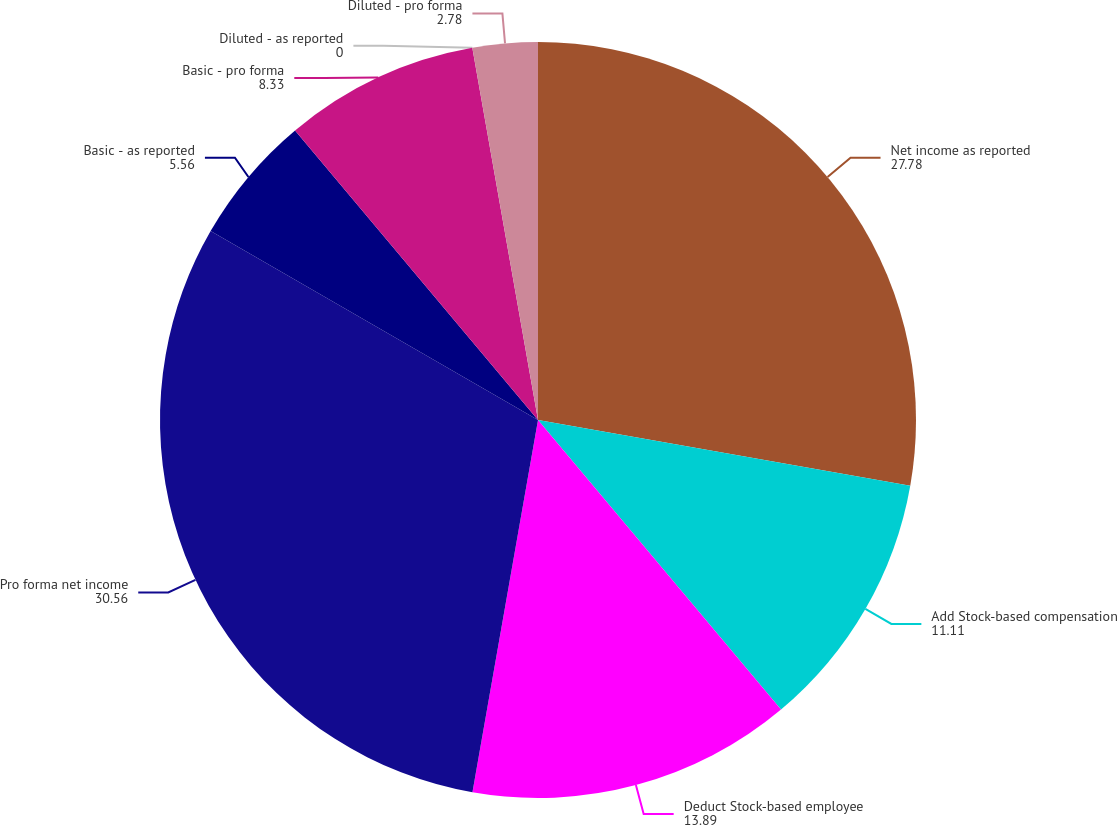<chart> <loc_0><loc_0><loc_500><loc_500><pie_chart><fcel>Net income as reported<fcel>Add Stock-based compensation<fcel>Deduct Stock-based employee<fcel>Pro forma net income<fcel>Basic - as reported<fcel>Basic - pro forma<fcel>Diluted - as reported<fcel>Diluted - pro forma<nl><fcel>27.78%<fcel>11.11%<fcel>13.89%<fcel>30.56%<fcel>5.56%<fcel>8.33%<fcel>0.0%<fcel>2.78%<nl></chart> 